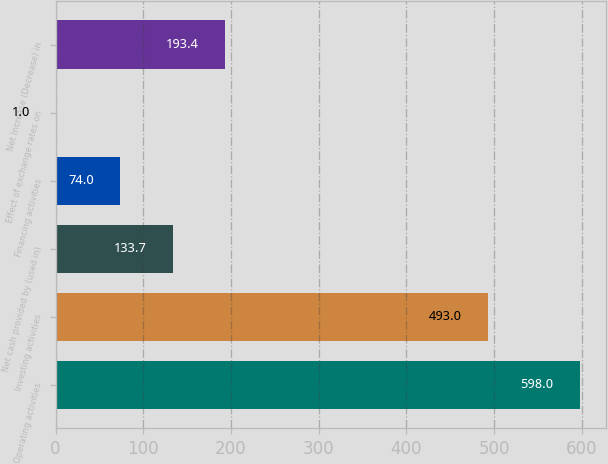Convert chart. <chart><loc_0><loc_0><loc_500><loc_500><bar_chart><fcel>Operating activities<fcel>Investing activities<fcel>Net cash provided by (used in)<fcel>Financing activities<fcel>Effect of exchange rates on<fcel>Net Increase (Decrease) in<nl><fcel>598<fcel>493<fcel>133.7<fcel>74<fcel>1<fcel>193.4<nl></chart> 